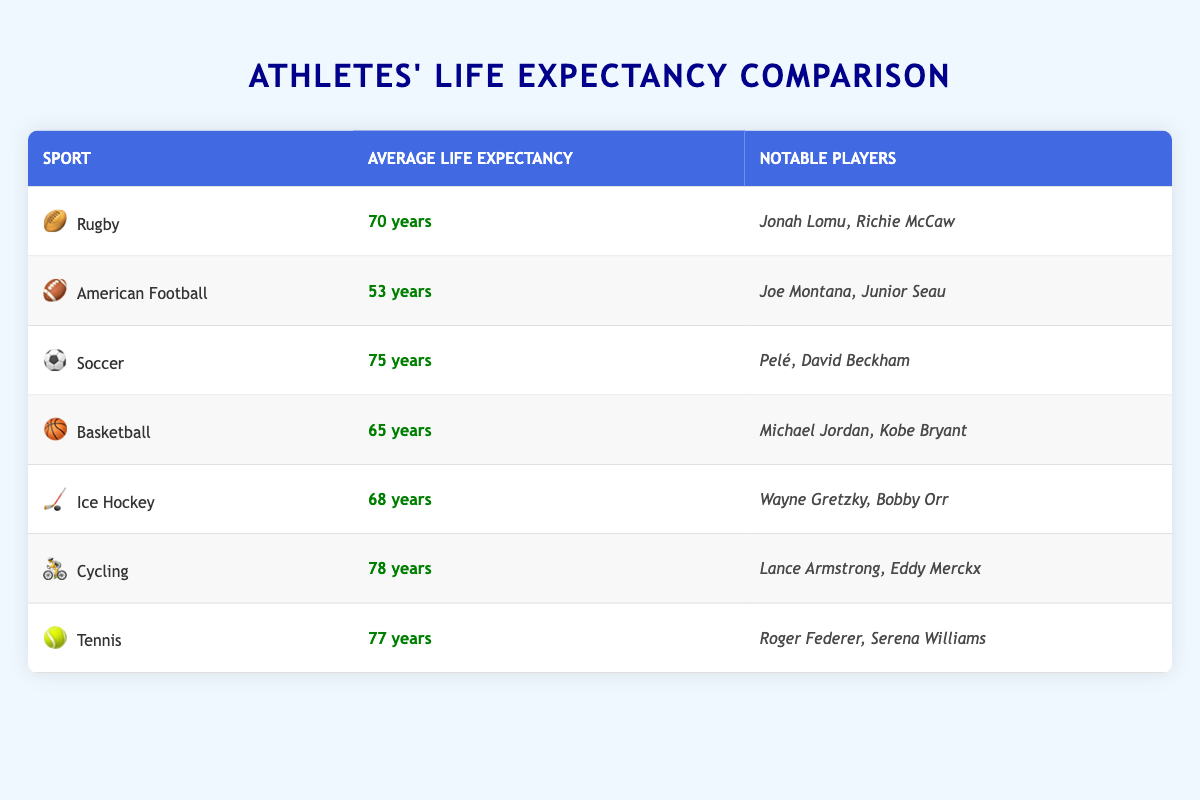What is the average life expectancy of rugby players? The table lists the average life expectancy of rugby players as 70 years, which is shown directly in the "Average Life Expectancy" column next to the "Rugby" row.
Answer: 70 years Which sport has the highest average life expectancy? By examining the "Average Life Expectancy" column, cycling has the highest average life expectancy at 78 years, as it is the highest value in that column.
Answer: Cycling How much longer do soccer players live, on average, compared to American football players? From the table, soccer players have an average life expectancy of 75 years, while American football players have 53 years. The difference is 75 - 53 = 22 years, which means soccer players live 22 years longer on average than American football players.
Answer: 22 years Are there any notable rugby players listed in the table? Yes, the table mentions notable rugby players, specifically Jonah Lomu and Richie McCaw, listed in the "Notable Players" column for the rugby sport row.
Answer: Yes What is the combined average life expectancy of tennis and ice hockey players? The average life expectancy of tennis players is 77 years, while ice hockey players have 68 years. Adding these together (77 + 68) gives a total of 145 years. To find the average, we divide by 2: 145 / 2 = 72.5 years. Thus, the combined average life expectancy of tennis and ice hockey players is 72.5 years.
Answer: 72.5 years Is the average life expectancy of basketball players greater than that of rugby players? The table indicates that basketball players have an average life expectancy of 65 years and rugby players have 70 years. Therefore, it's true that basketball players live shorter lives since 65 is less than 70.
Answer: No What percentage difference is there in average life expectancy between cycling and rugby? Cycling has an average life expectancy of 78 years, while rugby players have 70 years. The difference is 78 - 70 = 8 years. To find the percentage difference: (8 / 70) * 100 = 11.43%. Therefore, there is an approximately 11.43% difference between cycling and rugby players' life expectancy, showing cycling players live longer.
Answer: 11.43% Which sport has a lower average life expectancy: basketball or ice hockey? The average life expectancy for basketball players is 65 years, while for ice hockey players, it is 68 years. Since 65 is less than 68, basketball has a lower average life expectancy than ice hockey.
Answer: Basketball 